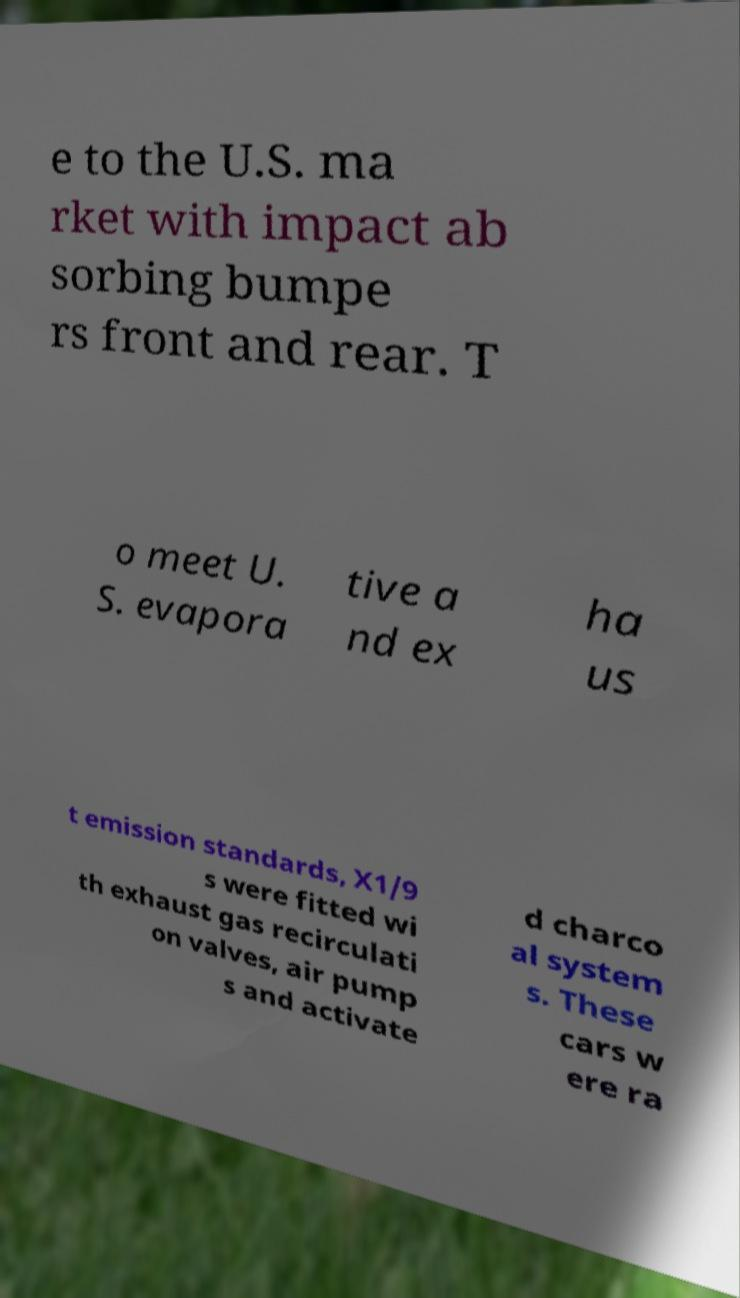Please read and relay the text visible in this image. What does it say? e to the U.S. ma rket with impact ab sorbing bumpe rs front and rear. T o meet U. S. evapora tive a nd ex ha us t emission standards, X1/9 s were fitted wi th exhaust gas recirculati on valves, air pump s and activate d charco al system s. These cars w ere ra 